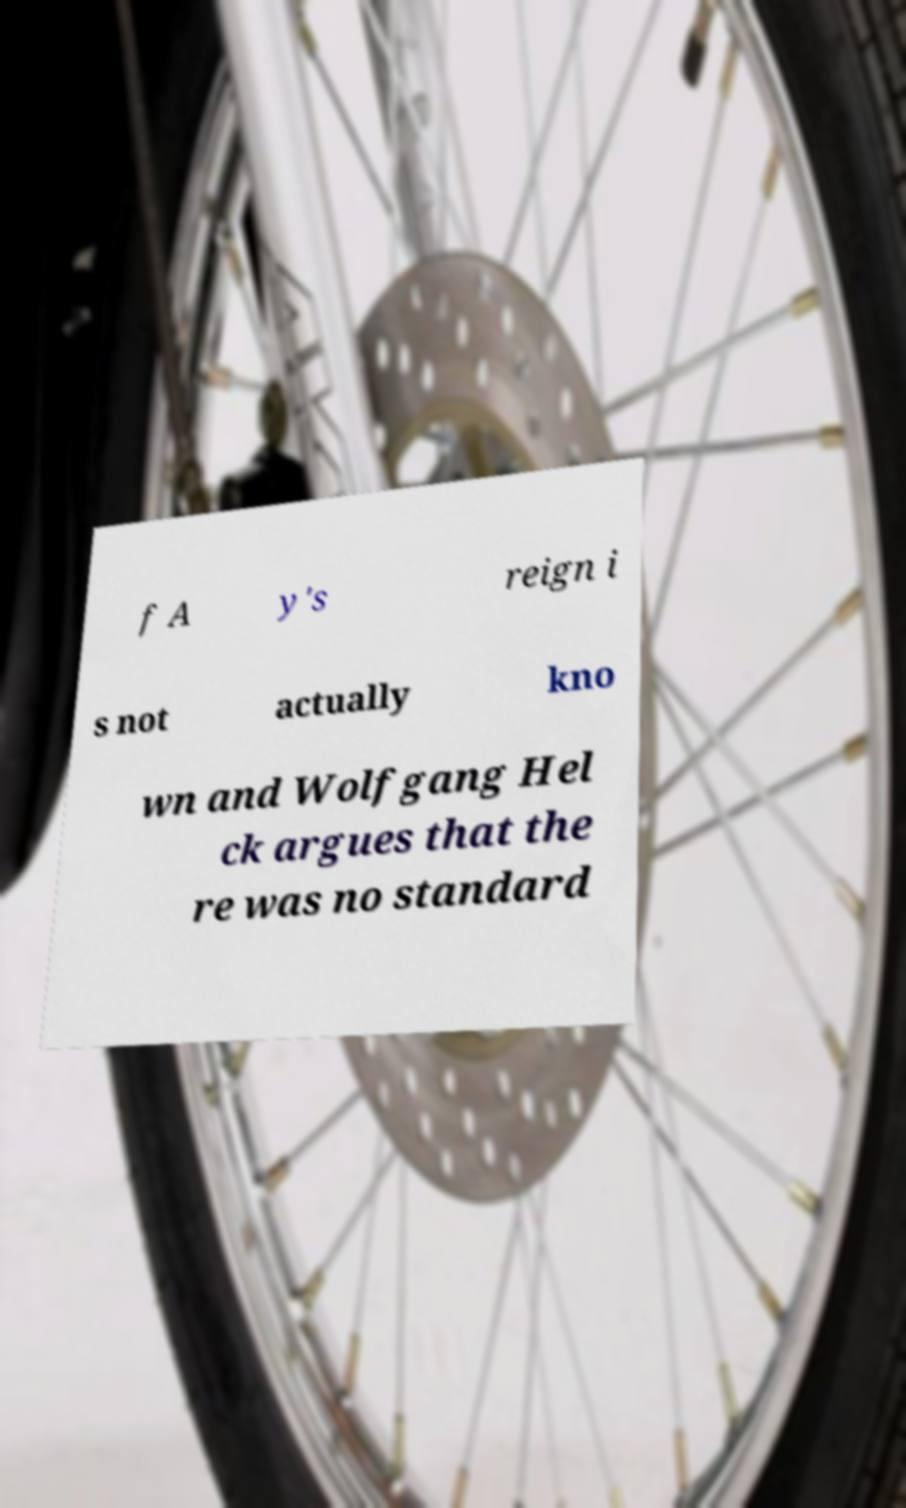What messages or text are displayed in this image? I need them in a readable, typed format. f A y's reign i s not actually kno wn and Wolfgang Hel ck argues that the re was no standard 